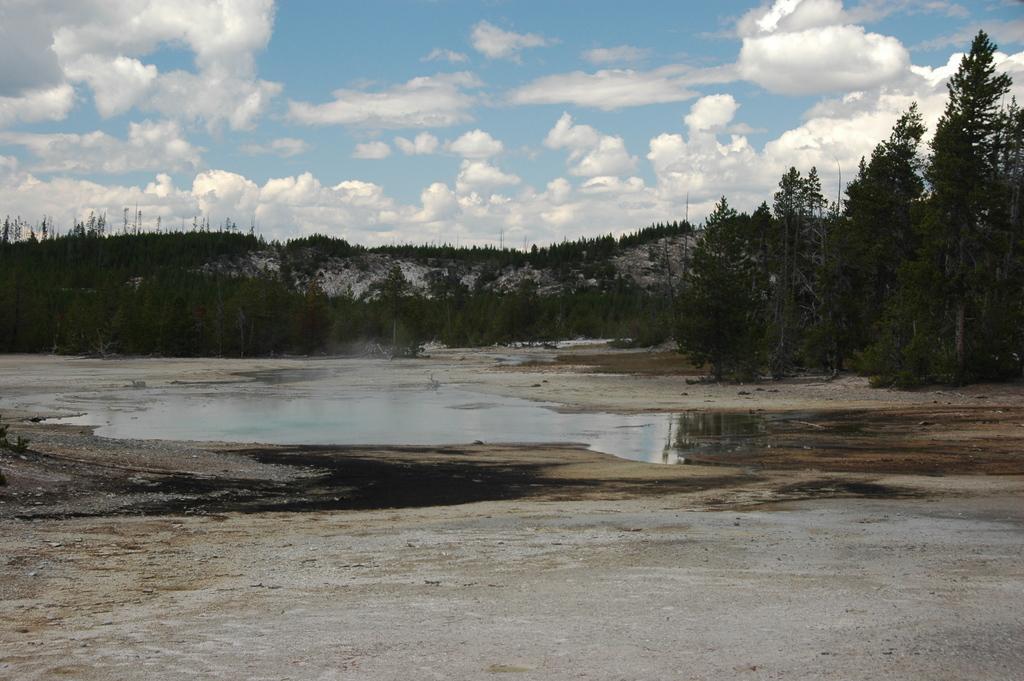Please provide a concise description of this image. At the bottom of this image, there is a dry land. In the background, there is water, there are trees, plants, a mountain and there are clouds in the blue sky. 